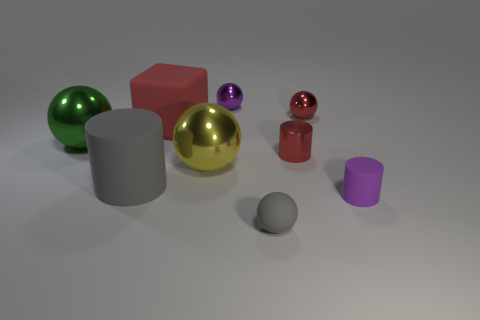Is there any other thing that is the same shape as the red matte thing?
Your answer should be compact. No. Is the number of shiny balls on the left side of the large green metallic ball less than the number of large gray rubber things?
Your answer should be very brief. Yes. The red thing that is made of the same material as the large gray thing is what shape?
Give a very brief answer. Cube. How many other objects are there of the same shape as the big red object?
Your answer should be compact. 0. How many yellow objects are large things or metal spheres?
Your answer should be very brief. 1. Is the green object the same shape as the tiny purple rubber thing?
Provide a short and direct response. No. Are there any big cylinders that are behind the small purple thing behind the yellow metal object?
Ensure brevity in your answer.  No. Is the number of big things in front of the large gray rubber object the same as the number of tiny red metallic spheres?
Offer a terse response. No. How many other things are the same size as the yellow metal sphere?
Your answer should be compact. 3. Are the large thing behind the big green object and the big ball behind the red metal cylinder made of the same material?
Provide a short and direct response. No. 